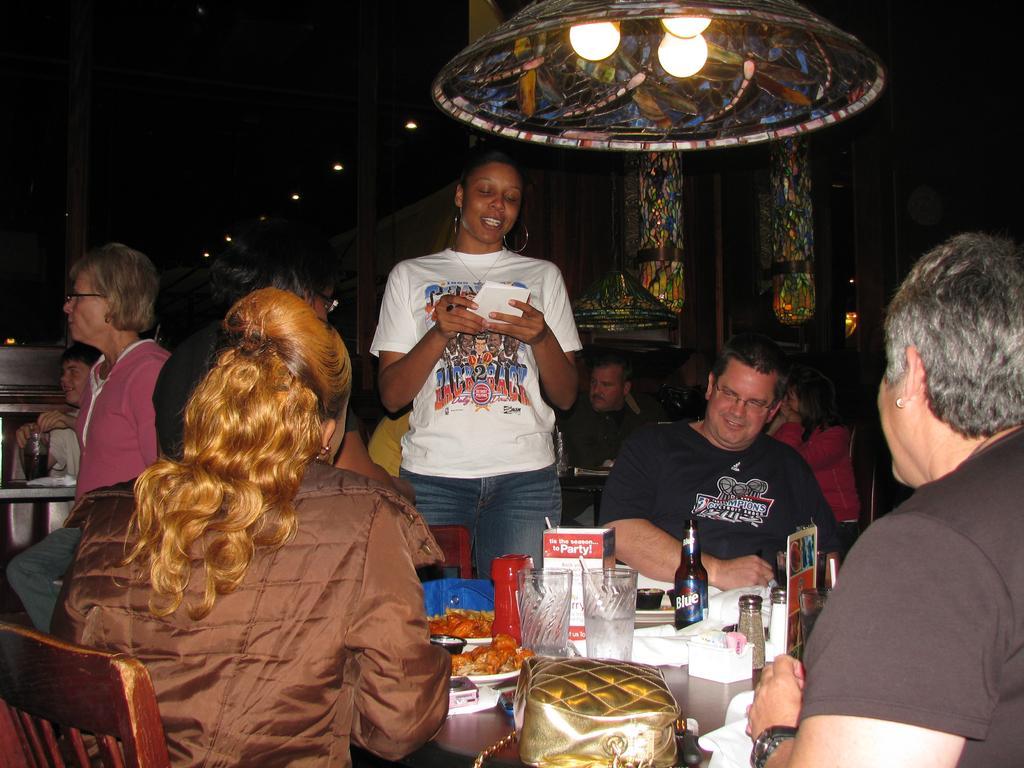Please provide a concise description of this image. In the image there are group of people. There are bottles, plates, food, bag on the table and at the top there are lights. 